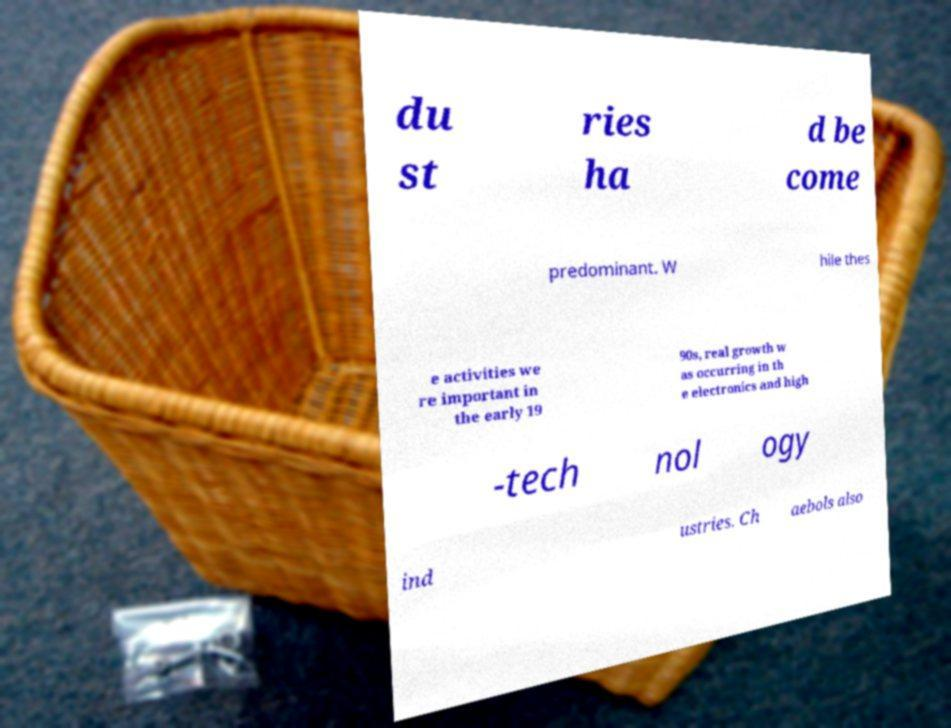There's text embedded in this image that I need extracted. Can you transcribe it verbatim? du st ries ha d be come predominant. W hile thes e activities we re important in the early 19 90s, real growth w as occurring in th e electronics and high -tech nol ogy ind ustries. Ch aebols also 